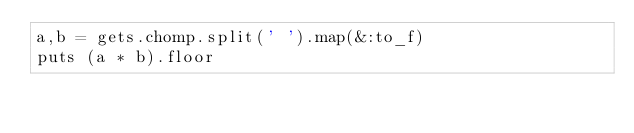<code> <loc_0><loc_0><loc_500><loc_500><_Ruby_>a,b = gets.chomp.split(' ').map(&:to_f)
puts (a * b).floor
</code> 